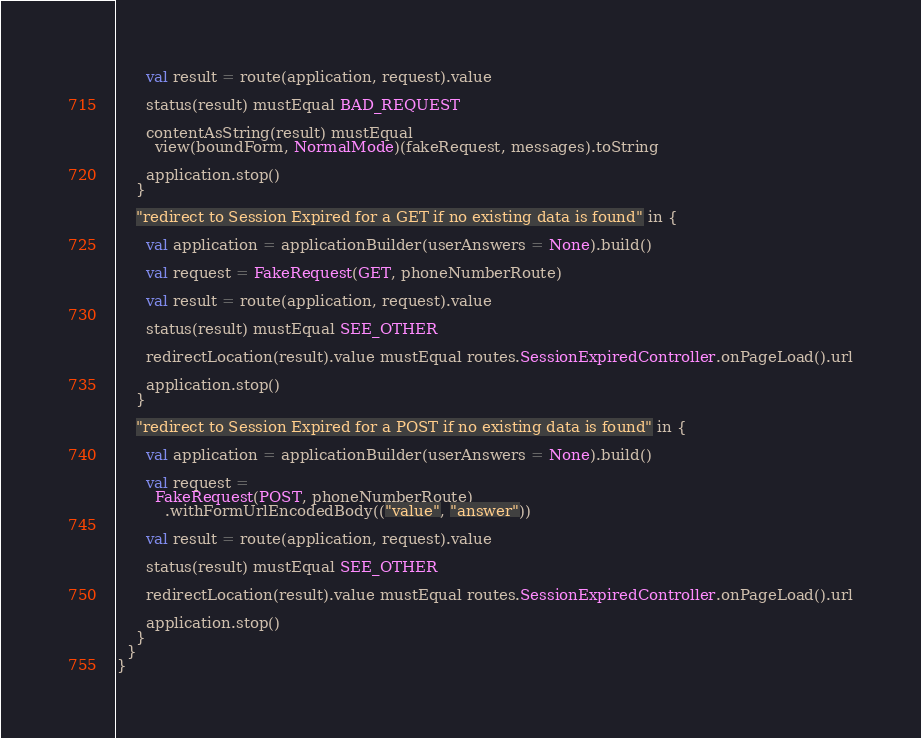Convert code to text. <code><loc_0><loc_0><loc_500><loc_500><_Scala_>
      val result = route(application, request).value

      status(result) mustEqual BAD_REQUEST

      contentAsString(result) mustEqual
        view(boundForm, NormalMode)(fakeRequest, messages).toString

      application.stop()
    }

    "redirect to Session Expired for a GET if no existing data is found" in {

      val application = applicationBuilder(userAnswers = None).build()

      val request = FakeRequest(GET, phoneNumberRoute)

      val result = route(application, request).value

      status(result) mustEqual SEE_OTHER

      redirectLocation(result).value mustEqual routes.SessionExpiredController.onPageLoad().url

      application.stop()
    }

    "redirect to Session Expired for a POST if no existing data is found" in {

      val application = applicationBuilder(userAnswers = None).build()

      val request =
        FakeRequest(POST, phoneNumberRoute)
          .withFormUrlEncodedBody(("value", "answer"))

      val result = route(application, request).value

      status(result) mustEqual SEE_OTHER

      redirectLocation(result).value mustEqual routes.SessionExpiredController.onPageLoad().url

      application.stop()
    }
  }
}
</code> 